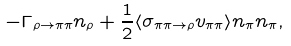Convert formula to latex. <formula><loc_0><loc_0><loc_500><loc_500>- \Gamma _ { \rho \to \pi \pi } n _ { \rho } + \frac { 1 } { 2 } \langle \sigma _ { \pi \pi \to \rho } v _ { \pi \pi } \rangle n _ { \pi } n _ { \pi } ,</formula> 